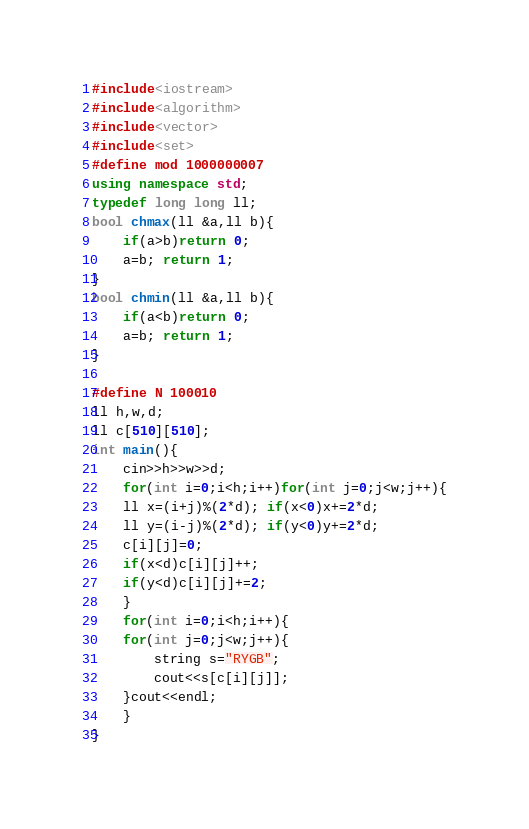Convert code to text. <code><loc_0><loc_0><loc_500><loc_500><_C++_>#include<iostream>
#include<algorithm>
#include<vector>
#include<set>
#define mod 1000000007
using namespace std;
typedef long long ll;
bool chmax(ll &a,ll b){
    if(a>b)return 0;
    a=b; return 1;
}
bool chmin(ll &a,ll b){
    if(a<b)return 0;
    a=b; return 1;
}

#define N 100010
ll h,w,d;
ll c[510][510];
int main(){
    cin>>h>>w>>d;
    for(int i=0;i<h;i++)for(int j=0;j<w;j++){
	ll x=(i+j)%(2*d); if(x<0)x+=2*d;
	ll y=(i-j)%(2*d); if(y<0)y+=2*d;
	c[i][j]=0;
	if(x<d)c[i][j]++;
	if(y<d)c[i][j]+=2;
    }
    for(int i=0;i<h;i++){
	for(int j=0;j<w;j++){
	    string s="RYGB";
	    cout<<s[c[i][j]];
	}cout<<endl;
    }
}

</code> 